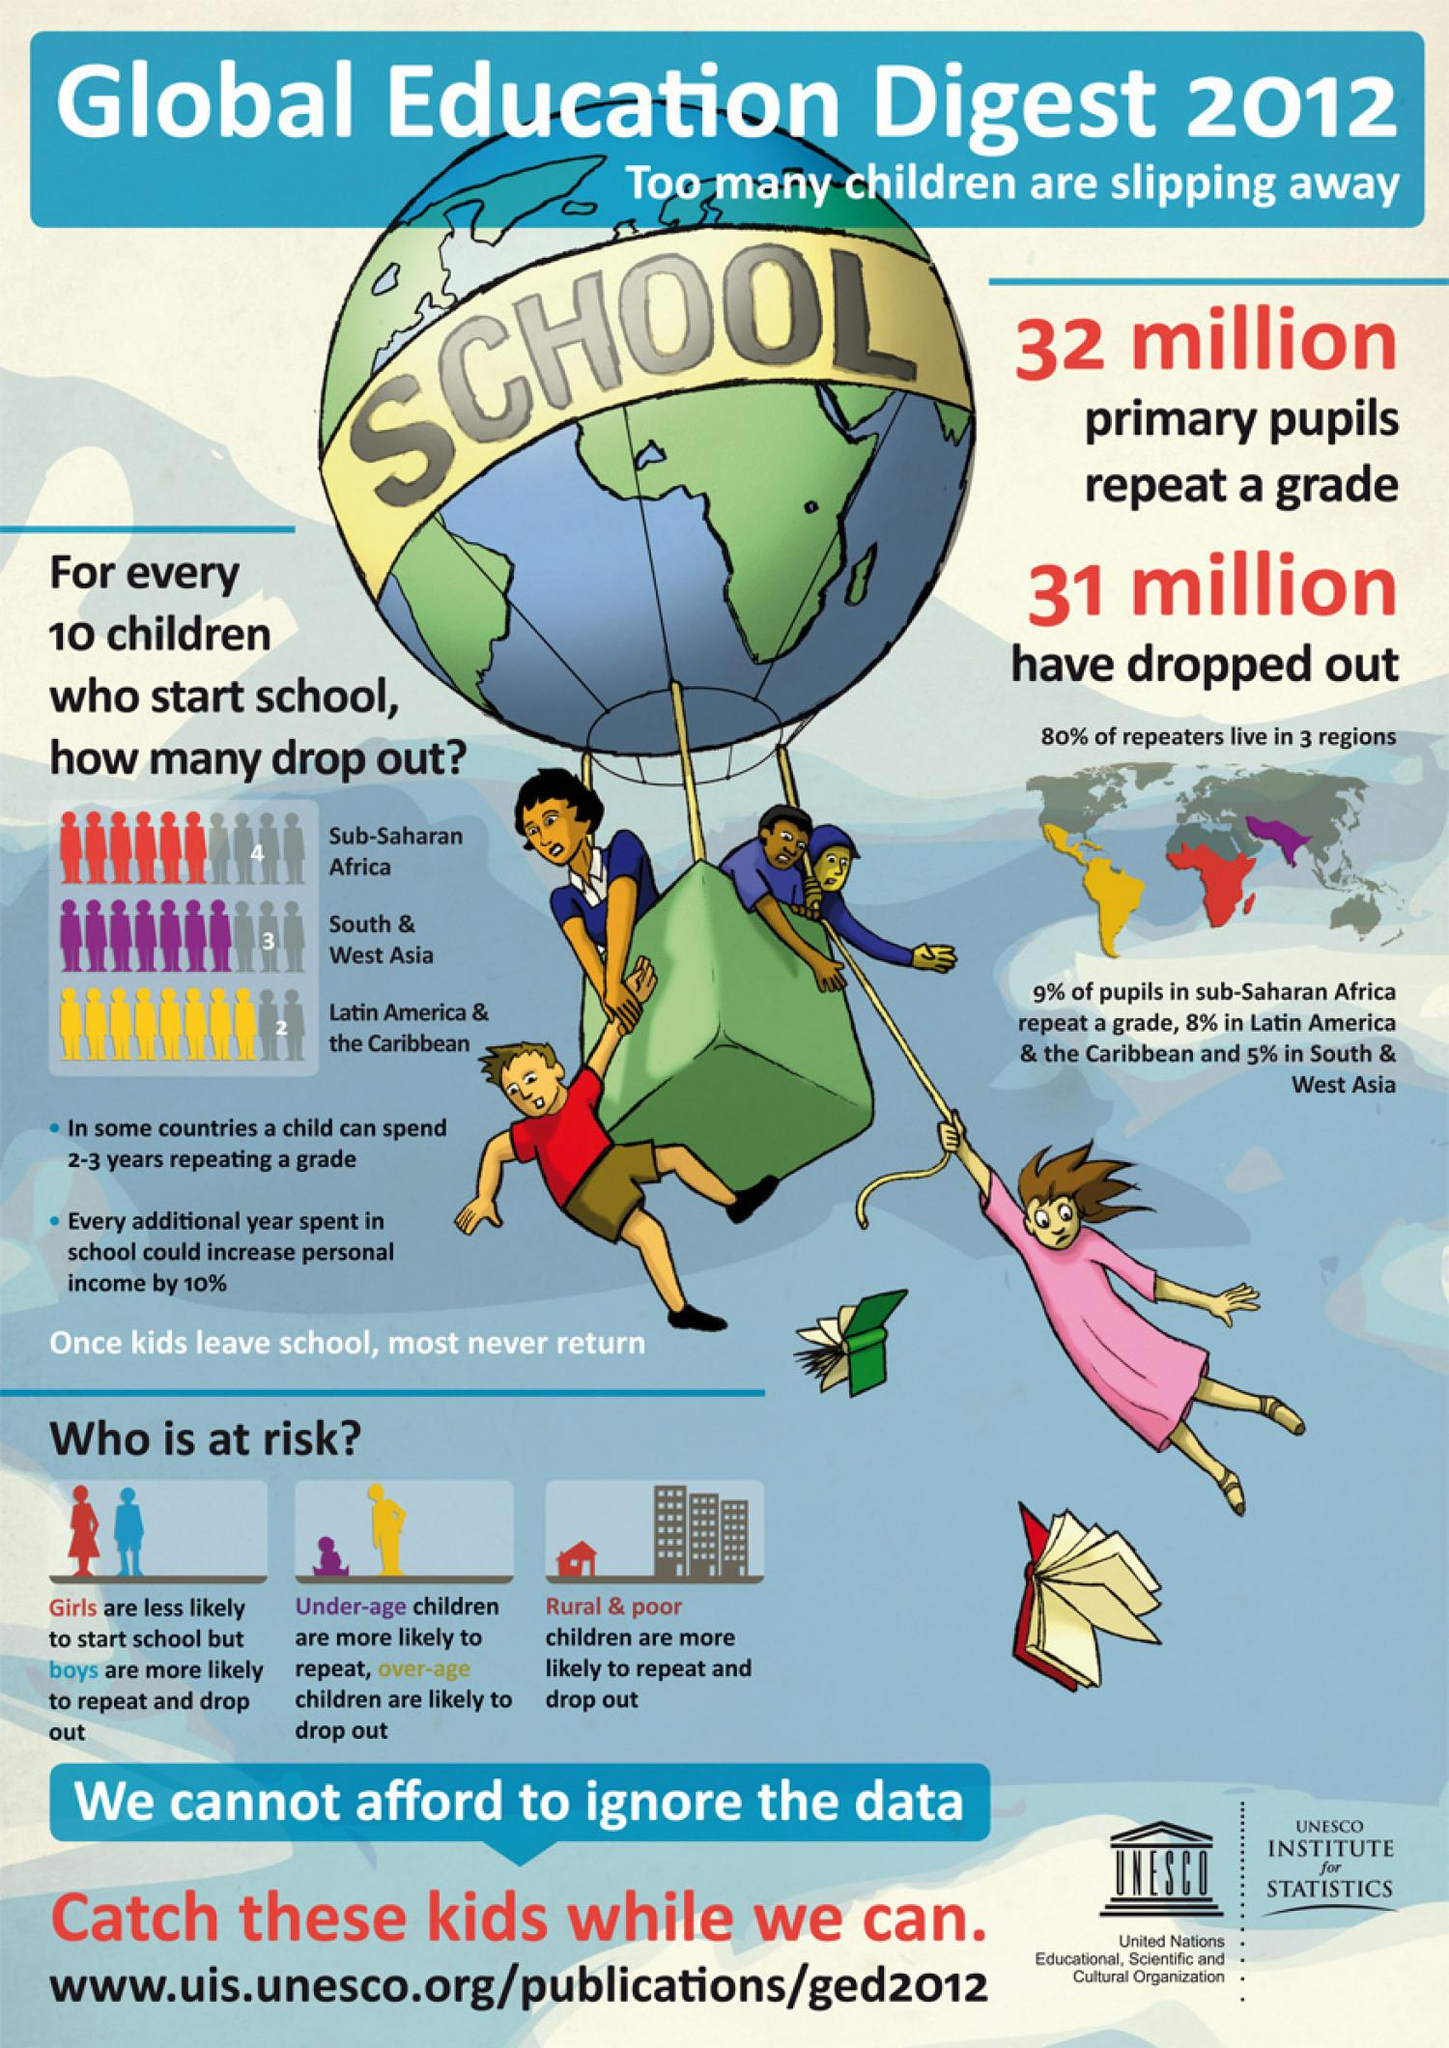Specify some key components in this picture. South & West Asia has the second lowest dropout rate, with only 1% of students dropping out for every ten students. 